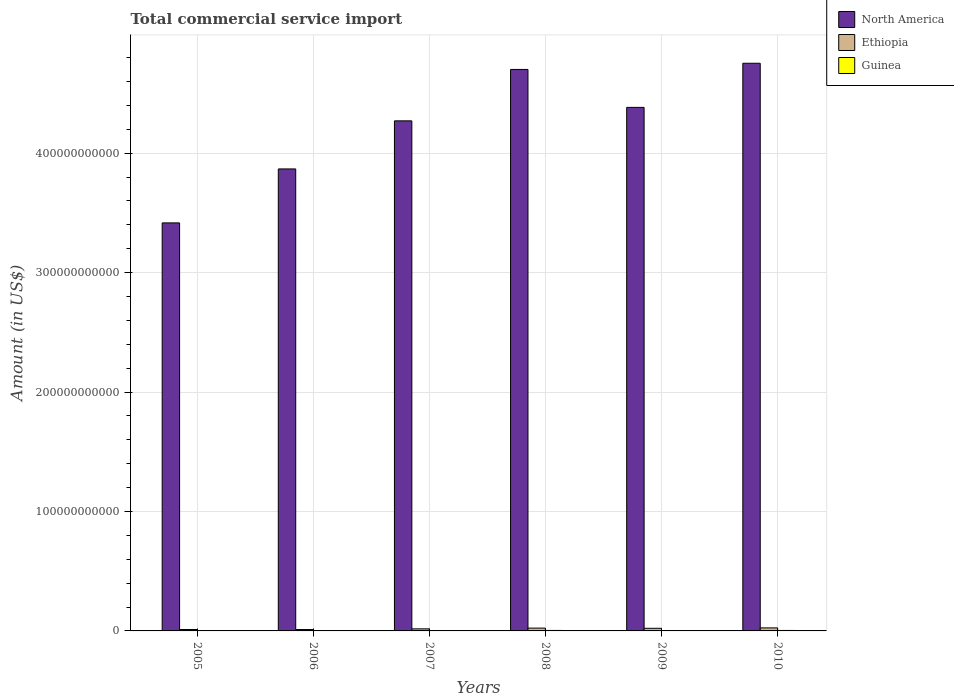Are the number of bars per tick equal to the number of legend labels?
Offer a terse response. Yes. How many bars are there on the 4th tick from the left?
Your response must be concise. 3. How many bars are there on the 6th tick from the right?
Give a very brief answer. 3. What is the total commercial service import in North America in 2007?
Provide a short and direct response. 4.27e+11. Across all years, what is the maximum total commercial service import in North America?
Give a very brief answer. 4.75e+11. Across all years, what is the minimum total commercial service import in North America?
Give a very brief answer. 3.42e+11. In which year was the total commercial service import in North America minimum?
Your answer should be very brief. 2005. What is the total total commercial service import in Guinea in the graph?
Your answer should be compact. 1.79e+09. What is the difference between the total commercial service import in North America in 2008 and that in 2009?
Provide a succinct answer. 3.18e+1. What is the difference between the total commercial service import in Ethiopia in 2007 and the total commercial service import in Guinea in 2006?
Provide a short and direct response. 1.49e+09. What is the average total commercial service import in North America per year?
Make the answer very short. 4.23e+11. In the year 2006, what is the difference between the total commercial service import in North America and total commercial service import in Guinea?
Your answer should be compact. 3.87e+11. What is the ratio of the total commercial service import in Guinea in 2007 to that in 2009?
Keep it short and to the point. 0.88. Is the total commercial service import in Guinea in 2005 less than that in 2008?
Ensure brevity in your answer.  Yes. Is the difference between the total commercial service import in North America in 2007 and 2010 greater than the difference between the total commercial service import in Guinea in 2007 and 2010?
Your response must be concise. No. What is the difference between the highest and the second highest total commercial service import in Ethiopia?
Your response must be concise. 1.73e+08. What is the difference between the highest and the lowest total commercial service import in Ethiopia?
Give a very brief answer. 1.38e+09. In how many years, is the total commercial service import in Ethiopia greater than the average total commercial service import in Ethiopia taken over all years?
Ensure brevity in your answer.  3. What does the 2nd bar from the left in 2006 represents?
Offer a terse response. Ethiopia. What does the 3rd bar from the right in 2008 represents?
Provide a short and direct response. North America. Is it the case that in every year, the sum of the total commercial service import in North America and total commercial service import in Guinea is greater than the total commercial service import in Ethiopia?
Ensure brevity in your answer.  Yes. How many years are there in the graph?
Your answer should be compact. 6. What is the difference between two consecutive major ticks on the Y-axis?
Your response must be concise. 1.00e+11. Are the values on the major ticks of Y-axis written in scientific E-notation?
Give a very brief answer. No. Does the graph contain grids?
Keep it short and to the point. Yes. How many legend labels are there?
Provide a short and direct response. 3. What is the title of the graph?
Provide a short and direct response. Total commercial service import. What is the label or title of the Y-axis?
Make the answer very short. Amount (in US$). What is the Amount (in US$) in North America in 2005?
Provide a succinct answer. 3.42e+11. What is the Amount (in US$) of Ethiopia in 2005?
Provide a succinct answer. 1.18e+09. What is the Amount (in US$) in Guinea in 2005?
Ensure brevity in your answer.  2.14e+08. What is the Amount (in US$) of North America in 2006?
Your answer should be very brief. 3.87e+11. What is the Amount (in US$) in Ethiopia in 2006?
Your answer should be compact. 1.15e+09. What is the Amount (in US$) in Guinea in 2006?
Your response must be concise. 2.38e+08. What is the Amount (in US$) of North America in 2007?
Offer a very short reply. 4.27e+11. What is the Amount (in US$) of Ethiopia in 2007?
Your response must be concise. 1.73e+09. What is the Amount (in US$) of Guinea in 2007?
Your answer should be very brief. 2.59e+08. What is the Amount (in US$) in North America in 2008?
Provide a succinct answer. 4.70e+11. What is the Amount (in US$) of Ethiopia in 2008?
Provide a succinct answer. 2.36e+09. What is the Amount (in US$) of Guinea in 2008?
Keep it short and to the point. 4.00e+08. What is the Amount (in US$) of North America in 2009?
Make the answer very short. 4.38e+11. What is the Amount (in US$) in Ethiopia in 2009?
Your answer should be compact. 2.19e+09. What is the Amount (in US$) of Guinea in 2009?
Keep it short and to the point. 2.94e+08. What is the Amount (in US$) of North America in 2010?
Offer a very short reply. 4.75e+11. What is the Amount (in US$) of Ethiopia in 2010?
Keep it short and to the point. 2.53e+09. What is the Amount (in US$) of Guinea in 2010?
Give a very brief answer. 3.87e+08. Across all years, what is the maximum Amount (in US$) in North America?
Keep it short and to the point. 4.75e+11. Across all years, what is the maximum Amount (in US$) of Ethiopia?
Offer a terse response. 2.53e+09. Across all years, what is the maximum Amount (in US$) of Guinea?
Give a very brief answer. 4.00e+08. Across all years, what is the minimum Amount (in US$) in North America?
Give a very brief answer. 3.42e+11. Across all years, what is the minimum Amount (in US$) in Ethiopia?
Ensure brevity in your answer.  1.15e+09. Across all years, what is the minimum Amount (in US$) of Guinea?
Your answer should be compact. 2.14e+08. What is the total Amount (in US$) in North America in the graph?
Provide a short and direct response. 2.54e+12. What is the total Amount (in US$) of Ethiopia in the graph?
Your response must be concise. 1.11e+1. What is the total Amount (in US$) of Guinea in the graph?
Your answer should be compact. 1.79e+09. What is the difference between the Amount (in US$) in North America in 2005 and that in 2006?
Provide a succinct answer. -4.52e+1. What is the difference between the Amount (in US$) of Ethiopia in 2005 and that in 2006?
Keep it short and to the point. 2.38e+07. What is the difference between the Amount (in US$) of Guinea in 2005 and that in 2006?
Your response must be concise. -2.41e+07. What is the difference between the Amount (in US$) of North America in 2005 and that in 2007?
Offer a very short reply. -8.54e+1. What is the difference between the Amount (in US$) in Ethiopia in 2005 and that in 2007?
Keep it short and to the point. -5.55e+08. What is the difference between the Amount (in US$) of Guinea in 2005 and that in 2007?
Your answer should be very brief. -4.42e+07. What is the difference between the Amount (in US$) in North America in 2005 and that in 2008?
Your answer should be compact. -1.28e+11. What is the difference between the Amount (in US$) in Ethiopia in 2005 and that in 2008?
Make the answer very short. -1.18e+09. What is the difference between the Amount (in US$) in Guinea in 2005 and that in 2008?
Your answer should be very brief. -1.86e+08. What is the difference between the Amount (in US$) of North America in 2005 and that in 2009?
Offer a very short reply. -9.67e+1. What is the difference between the Amount (in US$) in Ethiopia in 2005 and that in 2009?
Offer a very short reply. -1.01e+09. What is the difference between the Amount (in US$) of Guinea in 2005 and that in 2009?
Give a very brief answer. -7.92e+07. What is the difference between the Amount (in US$) of North America in 2005 and that in 2010?
Your answer should be compact. -1.34e+11. What is the difference between the Amount (in US$) of Ethiopia in 2005 and that in 2010?
Your response must be concise. -1.36e+09. What is the difference between the Amount (in US$) in Guinea in 2005 and that in 2010?
Offer a terse response. -1.73e+08. What is the difference between the Amount (in US$) in North America in 2006 and that in 2007?
Offer a terse response. -4.02e+1. What is the difference between the Amount (in US$) of Ethiopia in 2006 and that in 2007?
Your response must be concise. -5.79e+08. What is the difference between the Amount (in US$) of Guinea in 2006 and that in 2007?
Offer a terse response. -2.01e+07. What is the difference between the Amount (in US$) in North America in 2006 and that in 2008?
Make the answer very short. -8.33e+1. What is the difference between the Amount (in US$) of Ethiopia in 2006 and that in 2008?
Keep it short and to the point. -1.21e+09. What is the difference between the Amount (in US$) in Guinea in 2006 and that in 2008?
Your answer should be very brief. -1.62e+08. What is the difference between the Amount (in US$) in North America in 2006 and that in 2009?
Your answer should be very brief. -5.15e+1. What is the difference between the Amount (in US$) in Ethiopia in 2006 and that in 2009?
Make the answer very short. -1.03e+09. What is the difference between the Amount (in US$) in Guinea in 2006 and that in 2009?
Your answer should be very brief. -5.50e+07. What is the difference between the Amount (in US$) in North America in 2006 and that in 2010?
Your response must be concise. -8.85e+1. What is the difference between the Amount (in US$) in Ethiopia in 2006 and that in 2010?
Offer a very short reply. -1.38e+09. What is the difference between the Amount (in US$) of Guinea in 2006 and that in 2010?
Your answer should be very brief. -1.49e+08. What is the difference between the Amount (in US$) in North America in 2007 and that in 2008?
Make the answer very short. -4.30e+1. What is the difference between the Amount (in US$) of Ethiopia in 2007 and that in 2008?
Your answer should be very brief. -6.27e+08. What is the difference between the Amount (in US$) in Guinea in 2007 and that in 2008?
Offer a very short reply. -1.42e+08. What is the difference between the Amount (in US$) in North America in 2007 and that in 2009?
Give a very brief answer. -1.13e+1. What is the difference between the Amount (in US$) in Ethiopia in 2007 and that in 2009?
Keep it short and to the point. -4.53e+08. What is the difference between the Amount (in US$) in Guinea in 2007 and that in 2009?
Keep it short and to the point. -3.50e+07. What is the difference between the Amount (in US$) in North America in 2007 and that in 2010?
Provide a succinct answer. -4.82e+1. What is the difference between the Amount (in US$) of Ethiopia in 2007 and that in 2010?
Your answer should be compact. -8.00e+08. What is the difference between the Amount (in US$) of Guinea in 2007 and that in 2010?
Offer a very short reply. -1.29e+08. What is the difference between the Amount (in US$) in North America in 2008 and that in 2009?
Your answer should be compact. 3.18e+1. What is the difference between the Amount (in US$) in Ethiopia in 2008 and that in 2009?
Ensure brevity in your answer.  1.74e+08. What is the difference between the Amount (in US$) of Guinea in 2008 and that in 2009?
Offer a terse response. 1.07e+08. What is the difference between the Amount (in US$) in North America in 2008 and that in 2010?
Keep it short and to the point. -5.18e+09. What is the difference between the Amount (in US$) in Ethiopia in 2008 and that in 2010?
Your answer should be compact. -1.73e+08. What is the difference between the Amount (in US$) of Guinea in 2008 and that in 2010?
Ensure brevity in your answer.  1.30e+07. What is the difference between the Amount (in US$) of North America in 2009 and that in 2010?
Offer a very short reply. -3.70e+1. What is the difference between the Amount (in US$) in Ethiopia in 2009 and that in 2010?
Ensure brevity in your answer.  -3.47e+08. What is the difference between the Amount (in US$) of Guinea in 2009 and that in 2010?
Offer a terse response. -9.38e+07. What is the difference between the Amount (in US$) in North America in 2005 and the Amount (in US$) in Ethiopia in 2006?
Offer a terse response. 3.41e+11. What is the difference between the Amount (in US$) of North America in 2005 and the Amount (in US$) of Guinea in 2006?
Provide a short and direct response. 3.41e+11. What is the difference between the Amount (in US$) of Ethiopia in 2005 and the Amount (in US$) of Guinea in 2006?
Ensure brevity in your answer.  9.40e+08. What is the difference between the Amount (in US$) of North America in 2005 and the Amount (in US$) of Ethiopia in 2007?
Keep it short and to the point. 3.40e+11. What is the difference between the Amount (in US$) of North America in 2005 and the Amount (in US$) of Guinea in 2007?
Your response must be concise. 3.41e+11. What is the difference between the Amount (in US$) of Ethiopia in 2005 and the Amount (in US$) of Guinea in 2007?
Provide a short and direct response. 9.20e+08. What is the difference between the Amount (in US$) of North America in 2005 and the Amount (in US$) of Ethiopia in 2008?
Keep it short and to the point. 3.39e+11. What is the difference between the Amount (in US$) in North America in 2005 and the Amount (in US$) in Guinea in 2008?
Make the answer very short. 3.41e+11. What is the difference between the Amount (in US$) in Ethiopia in 2005 and the Amount (in US$) in Guinea in 2008?
Your answer should be very brief. 7.78e+08. What is the difference between the Amount (in US$) of North America in 2005 and the Amount (in US$) of Ethiopia in 2009?
Give a very brief answer. 3.39e+11. What is the difference between the Amount (in US$) of North America in 2005 and the Amount (in US$) of Guinea in 2009?
Ensure brevity in your answer.  3.41e+11. What is the difference between the Amount (in US$) in Ethiopia in 2005 and the Amount (in US$) in Guinea in 2009?
Keep it short and to the point. 8.85e+08. What is the difference between the Amount (in US$) in North America in 2005 and the Amount (in US$) in Ethiopia in 2010?
Ensure brevity in your answer.  3.39e+11. What is the difference between the Amount (in US$) of North America in 2005 and the Amount (in US$) of Guinea in 2010?
Your answer should be very brief. 3.41e+11. What is the difference between the Amount (in US$) in Ethiopia in 2005 and the Amount (in US$) in Guinea in 2010?
Your response must be concise. 7.91e+08. What is the difference between the Amount (in US$) of North America in 2006 and the Amount (in US$) of Ethiopia in 2007?
Offer a terse response. 3.85e+11. What is the difference between the Amount (in US$) of North America in 2006 and the Amount (in US$) of Guinea in 2007?
Your answer should be very brief. 3.87e+11. What is the difference between the Amount (in US$) of Ethiopia in 2006 and the Amount (in US$) of Guinea in 2007?
Keep it short and to the point. 8.96e+08. What is the difference between the Amount (in US$) of North America in 2006 and the Amount (in US$) of Ethiopia in 2008?
Make the answer very short. 3.84e+11. What is the difference between the Amount (in US$) of North America in 2006 and the Amount (in US$) of Guinea in 2008?
Your response must be concise. 3.86e+11. What is the difference between the Amount (in US$) in Ethiopia in 2006 and the Amount (in US$) in Guinea in 2008?
Make the answer very short. 7.54e+08. What is the difference between the Amount (in US$) of North America in 2006 and the Amount (in US$) of Ethiopia in 2009?
Your response must be concise. 3.85e+11. What is the difference between the Amount (in US$) of North America in 2006 and the Amount (in US$) of Guinea in 2009?
Your answer should be compact. 3.87e+11. What is the difference between the Amount (in US$) of Ethiopia in 2006 and the Amount (in US$) of Guinea in 2009?
Provide a short and direct response. 8.61e+08. What is the difference between the Amount (in US$) in North America in 2006 and the Amount (in US$) in Ethiopia in 2010?
Your answer should be very brief. 3.84e+11. What is the difference between the Amount (in US$) of North America in 2006 and the Amount (in US$) of Guinea in 2010?
Ensure brevity in your answer.  3.86e+11. What is the difference between the Amount (in US$) of Ethiopia in 2006 and the Amount (in US$) of Guinea in 2010?
Give a very brief answer. 7.67e+08. What is the difference between the Amount (in US$) of North America in 2007 and the Amount (in US$) of Ethiopia in 2008?
Ensure brevity in your answer.  4.25e+11. What is the difference between the Amount (in US$) in North America in 2007 and the Amount (in US$) in Guinea in 2008?
Make the answer very short. 4.27e+11. What is the difference between the Amount (in US$) in Ethiopia in 2007 and the Amount (in US$) in Guinea in 2008?
Your answer should be very brief. 1.33e+09. What is the difference between the Amount (in US$) of North America in 2007 and the Amount (in US$) of Ethiopia in 2009?
Offer a terse response. 4.25e+11. What is the difference between the Amount (in US$) in North America in 2007 and the Amount (in US$) in Guinea in 2009?
Make the answer very short. 4.27e+11. What is the difference between the Amount (in US$) of Ethiopia in 2007 and the Amount (in US$) of Guinea in 2009?
Keep it short and to the point. 1.44e+09. What is the difference between the Amount (in US$) of North America in 2007 and the Amount (in US$) of Ethiopia in 2010?
Keep it short and to the point. 4.25e+11. What is the difference between the Amount (in US$) in North America in 2007 and the Amount (in US$) in Guinea in 2010?
Make the answer very short. 4.27e+11. What is the difference between the Amount (in US$) of Ethiopia in 2007 and the Amount (in US$) of Guinea in 2010?
Offer a terse response. 1.35e+09. What is the difference between the Amount (in US$) in North America in 2008 and the Amount (in US$) in Ethiopia in 2009?
Provide a short and direct response. 4.68e+11. What is the difference between the Amount (in US$) in North America in 2008 and the Amount (in US$) in Guinea in 2009?
Your answer should be very brief. 4.70e+11. What is the difference between the Amount (in US$) in Ethiopia in 2008 and the Amount (in US$) in Guinea in 2009?
Offer a terse response. 2.07e+09. What is the difference between the Amount (in US$) of North America in 2008 and the Amount (in US$) of Ethiopia in 2010?
Provide a succinct answer. 4.68e+11. What is the difference between the Amount (in US$) of North America in 2008 and the Amount (in US$) of Guinea in 2010?
Your response must be concise. 4.70e+11. What is the difference between the Amount (in US$) in Ethiopia in 2008 and the Amount (in US$) in Guinea in 2010?
Ensure brevity in your answer.  1.97e+09. What is the difference between the Amount (in US$) of North America in 2009 and the Amount (in US$) of Ethiopia in 2010?
Your answer should be compact. 4.36e+11. What is the difference between the Amount (in US$) in North America in 2009 and the Amount (in US$) in Guinea in 2010?
Ensure brevity in your answer.  4.38e+11. What is the difference between the Amount (in US$) in Ethiopia in 2009 and the Amount (in US$) in Guinea in 2010?
Offer a very short reply. 1.80e+09. What is the average Amount (in US$) in North America per year?
Provide a short and direct response. 4.23e+11. What is the average Amount (in US$) of Ethiopia per year?
Make the answer very short. 1.86e+09. What is the average Amount (in US$) of Guinea per year?
Provide a succinct answer. 2.99e+08. In the year 2005, what is the difference between the Amount (in US$) in North America and Amount (in US$) in Ethiopia?
Offer a very short reply. 3.40e+11. In the year 2005, what is the difference between the Amount (in US$) in North America and Amount (in US$) in Guinea?
Your response must be concise. 3.41e+11. In the year 2005, what is the difference between the Amount (in US$) of Ethiopia and Amount (in US$) of Guinea?
Your answer should be very brief. 9.64e+08. In the year 2006, what is the difference between the Amount (in US$) of North America and Amount (in US$) of Ethiopia?
Offer a terse response. 3.86e+11. In the year 2006, what is the difference between the Amount (in US$) of North America and Amount (in US$) of Guinea?
Make the answer very short. 3.87e+11. In the year 2006, what is the difference between the Amount (in US$) in Ethiopia and Amount (in US$) in Guinea?
Make the answer very short. 9.16e+08. In the year 2007, what is the difference between the Amount (in US$) in North America and Amount (in US$) in Ethiopia?
Make the answer very short. 4.25e+11. In the year 2007, what is the difference between the Amount (in US$) of North America and Amount (in US$) of Guinea?
Offer a terse response. 4.27e+11. In the year 2007, what is the difference between the Amount (in US$) in Ethiopia and Amount (in US$) in Guinea?
Your answer should be very brief. 1.47e+09. In the year 2008, what is the difference between the Amount (in US$) in North America and Amount (in US$) in Ethiopia?
Make the answer very short. 4.68e+11. In the year 2008, what is the difference between the Amount (in US$) in North America and Amount (in US$) in Guinea?
Your response must be concise. 4.70e+11. In the year 2008, what is the difference between the Amount (in US$) in Ethiopia and Amount (in US$) in Guinea?
Provide a short and direct response. 1.96e+09. In the year 2009, what is the difference between the Amount (in US$) in North America and Amount (in US$) in Ethiopia?
Offer a very short reply. 4.36e+11. In the year 2009, what is the difference between the Amount (in US$) in North America and Amount (in US$) in Guinea?
Provide a short and direct response. 4.38e+11. In the year 2009, what is the difference between the Amount (in US$) of Ethiopia and Amount (in US$) of Guinea?
Your response must be concise. 1.89e+09. In the year 2010, what is the difference between the Amount (in US$) of North America and Amount (in US$) of Ethiopia?
Provide a succinct answer. 4.73e+11. In the year 2010, what is the difference between the Amount (in US$) of North America and Amount (in US$) of Guinea?
Your answer should be compact. 4.75e+11. In the year 2010, what is the difference between the Amount (in US$) of Ethiopia and Amount (in US$) of Guinea?
Give a very brief answer. 2.15e+09. What is the ratio of the Amount (in US$) of North America in 2005 to that in 2006?
Give a very brief answer. 0.88. What is the ratio of the Amount (in US$) of Ethiopia in 2005 to that in 2006?
Your answer should be very brief. 1.02. What is the ratio of the Amount (in US$) in Guinea in 2005 to that in 2006?
Provide a succinct answer. 0.9. What is the ratio of the Amount (in US$) in North America in 2005 to that in 2007?
Your answer should be compact. 0.8. What is the ratio of the Amount (in US$) in Ethiopia in 2005 to that in 2007?
Your answer should be compact. 0.68. What is the ratio of the Amount (in US$) of Guinea in 2005 to that in 2007?
Provide a short and direct response. 0.83. What is the ratio of the Amount (in US$) in North America in 2005 to that in 2008?
Make the answer very short. 0.73. What is the ratio of the Amount (in US$) in Ethiopia in 2005 to that in 2008?
Provide a succinct answer. 0.5. What is the ratio of the Amount (in US$) in Guinea in 2005 to that in 2008?
Offer a very short reply. 0.54. What is the ratio of the Amount (in US$) in North America in 2005 to that in 2009?
Offer a terse response. 0.78. What is the ratio of the Amount (in US$) of Ethiopia in 2005 to that in 2009?
Ensure brevity in your answer.  0.54. What is the ratio of the Amount (in US$) in Guinea in 2005 to that in 2009?
Ensure brevity in your answer.  0.73. What is the ratio of the Amount (in US$) of North America in 2005 to that in 2010?
Give a very brief answer. 0.72. What is the ratio of the Amount (in US$) of Ethiopia in 2005 to that in 2010?
Provide a short and direct response. 0.46. What is the ratio of the Amount (in US$) of Guinea in 2005 to that in 2010?
Keep it short and to the point. 0.55. What is the ratio of the Amount (in US$) of North America in 2006 to that in 2007?
Ensure brevity in your answer.  0.91. What is the ratio of the Amount (in US$) of Ethiopia in 2006 to that in 2007?
Your response must be concise. 0.67. What is the ratio of the Amount (in US$) in Guinea in 2006 to that in 2007?
Offer a terse response. 0.92. What is the ratio of the Amount (in US$) of North America in 2006 to that in 2008?
Keep it short and to the point. 0.82. What is the ratio of the Amount (in US$) of Ethiopia in 2006 to that in 2008?
Make the answer very short. 0.49. What is the ratio of the Amount (in US$) of Guinea in 2006 to that in 2008?
Give a very brief answer. 0.6. What is the ratio of the Amount (in US$) of North America in 2006 to that in 2009?
Give a very brief answer. 0.88. What is the ratio of the Amount (in US$) in Ethiopia in 2006 to that in 2009?
Ensure brevity in your answer.  0.53. What is the ratio of the Amount (in US$) of Guinea in 2006 to that in 2009?
Offer a very short reply. 0.81. What is the ratio of the Amount (in US$) of North America in 2006 to that in 2010?
Ensure brevity in your answer.  0.81. What is the ratio of the Amount (in US$) of Ethiopia in 2006 to that in 2010?
Keep it short and to the point. 0.46. What is the ratio of the Amount (in US$) in Guinea in 2006 to that in 2010?
Offer a terse response. 0.62. What is the ratio of the Amount (in US$) of North America in 2007 to that in 2008?
Provide a succinct answer. 0.91. What is the ratio of the Amount (in US$) of Ethiopia in 2007 to that in 2008?
Offer a very short reply. 0.73. What is the ratio of the Amount (in US$) in Guinea in 2007 to that in 2008?
Give a very brief answer. 0.65. What is the ratio of the Amount (in US$) in North America in 2007 to that in 2009?
Provide a short and direct response. 0.97. What is the ratio of the Amount (in US$) in Ethiopia in 2007 to that in 2009?
Offer a very short reply. 0.79. What is the ratio of the Amount (in US$) of Guinea in 2007 to that in 2009?
Your response must be concise. 0.88. What is the ratio of the Amount (in US$) of North America in 2007 to that in 2010?
Offer a terse response. 0.9. What is the ratio of the Amount (in US$) in Ethiopia in 2007 to that in 2010?
Offer a terse response. 0.68. What is the ratio of the Amount (in US$) of Guinea in 2007 to that in 2010?
Your answer should be compact. 0.67. What is the ratio of the Amount (in US$) of North America in 2008 to that in 2009?
Your response must be concise. 1.07. What is the ratio of the Amount (in US$) of Ethiopia in 2008 to that in 2009?
Offer a terse response. 1.08. What is the ratio of the Amount (in US$) in Guinea in 2008 to that in 2009?
Your answer should be very brief. 1.36. What is the ratio of the Amount (in US$) of Ethiopia in 2008 to that in 2010?
Your answer should be very brief. 0.93. What is the ratio of the Amount (in US$) in Guinea in 2008 to that in 2010?
Your answer should be very brief. 1.03. What is the ratio of the Amount (in US$) of North America in 2009 to that in 2010?
Give a very brief answer. 0.92. What is the ratio of the Amount (in US$) of Ethiopia in 2009 to that in 2010?
Offer a very short reply. 0.86. What is the ratio of the Amount (in US$) in Guinea in 2009 to that in 2010?
Ensure brevity in your answer.  0.76. What is the difference between the highest and the second highest Amount (in US$) of North America?
Give a very brief answer. 5.18e+09. What is the difference between the highest and the second highest Amount (in US$) of Ethiopia?
Ensure brevity in your answer.  1.73e+08. What is the difference between the highest and the second highest Amount (in US$) in Guinea?
Your answer should be very brief. 1.30e+07. What is the difference between the highest and the lowest Amount (in US$) of North America?
Make the answer very short. 1.34e+11. What is the difference between the highest and the lowest Amount (in US$) of Ethiopia?
Keep it short and to the point. 1.38e+09. What is the difference between the highest and the lowest Amount (in US$) of Guinea?
Your answer should be very brief. 1.86e+08. 